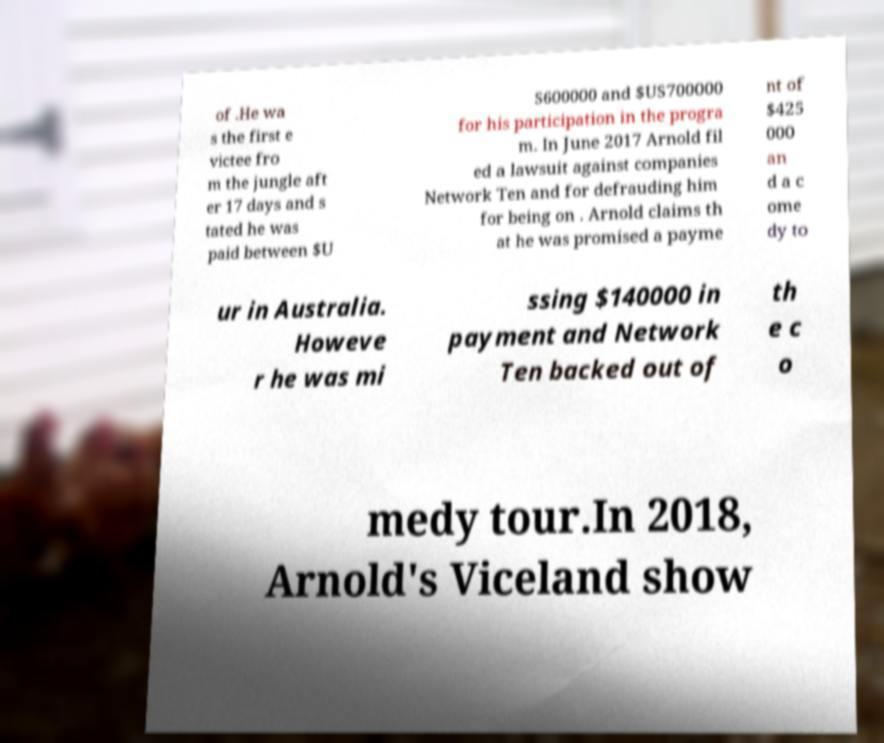Please read and relay the text visible in this image. What does it say? of .He wa s the first e victee fro m the jungle aft er 17 days and s tated he was paid between $U S600000 and $US700000 for his participation in the progra m. In June 2017 Arnold fil ed a lawsuit against companies Network Ten and for defrauding him for being on . Arnold claims th at he was promised a payme nt of $425 000 an d a c ome dy to ur in Australia. Howeve r he was mi ssing $140000 in payment and Network Ten backed out of th e c o medy tour.In 2018, Arnold's Viceland show 